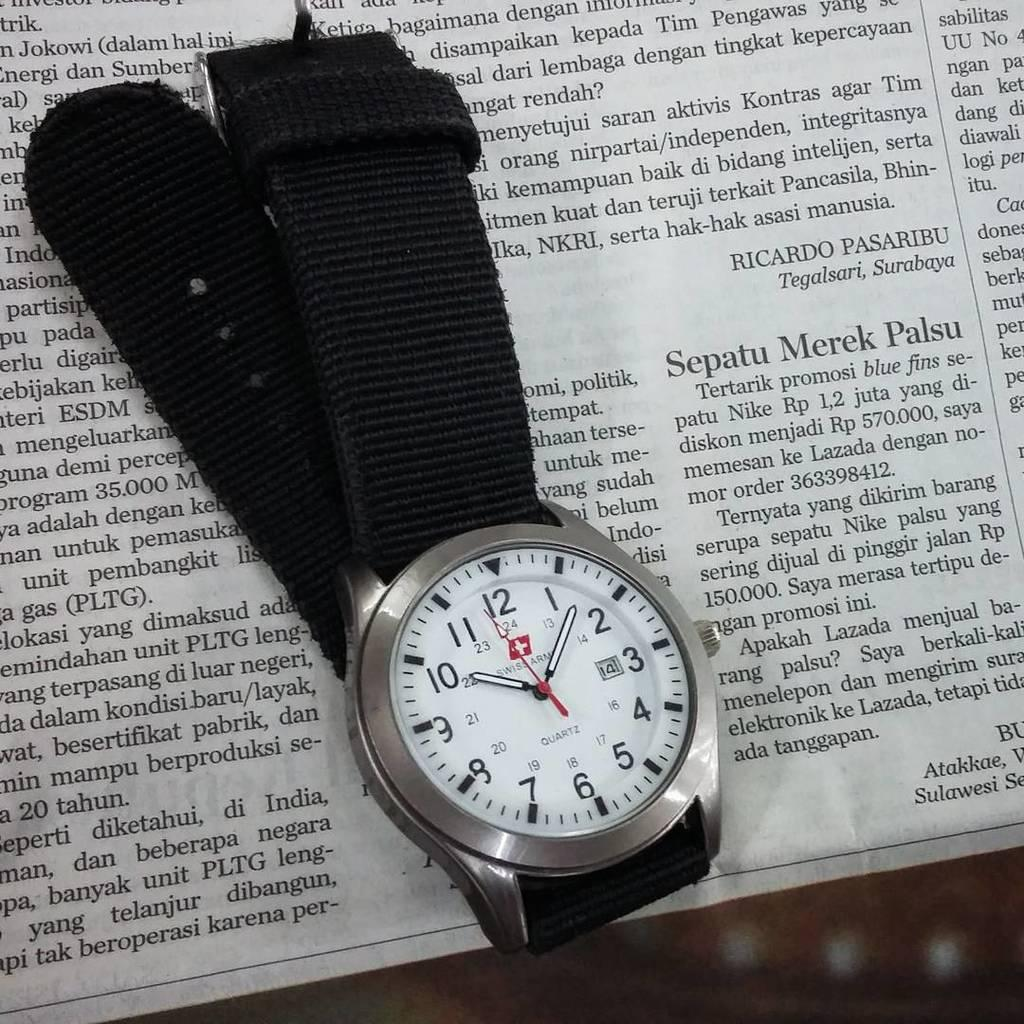What object is the main focus of the image? There is a wrist watch in the image. What is the color of the wrist watch? The wrist watch is black. What color is the dial of the wrist watch? The dial of the wrist watch is white. What is the wrist watch placed on in the image? The wrist watch is placed on a newspaper. How would you describe the background of the image? The background of the image is blurry. What type of card is being used to clean the wrist watch in the image? There is no card present in the image, and the wrist watch is not being cleaned. 